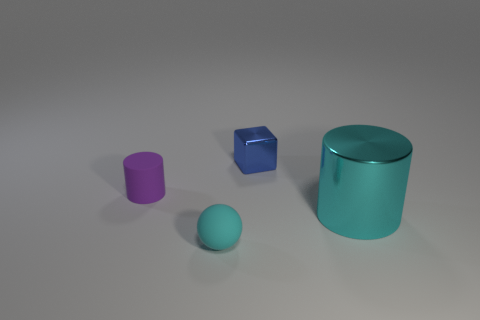Is there anything else that is the same size as the cyan shiny object?
Offer a very short reply. No. Is the size of the cyan object right of the cyan matte ball the same as the cyan object on the left side of the tiny blue cube?
Keep it short and to the point. No. Does the purple cylinder have the same size as the cyan object that is to the left of the cyan cylinder?
Offer a terse response. Yes. How big is the cyan shiny thing?
Give a very brief answer. Large. There is a tiny ball that is the same material as the tiny purple thing; what color is it?
Ensure brevity in your answer.  Cyan. How many tiny balls are the same material as the tiny purple cylinder?
Your response must be concise. 1. How many objects are either big red cubes or objects that are in front of the rubber cylinder?
Provide a succinct answer. 2. Does the cylinder that is to the left of the cyan cylinder have the same material as the tiny blue block?
Give a very brief answer. No. What is the color of the rubber sphere that is the same size as the blue cube?
Your answer should be compact. Cyan. Are there any small blue things of the same shape as the cyan rubber object?
Give a very brief answer. No. 